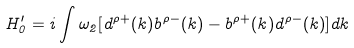<formula> <loc_0><loc_0><loc_500><loc_500>H _ { 0 } ^ { \prime } = i \int \omega _ { 2 } [ d ^ { \rho + } ( k ) b ^ { \rho - } ( k ) - b ^ { \rho + } ( k ) d ^ { \rho - } ( k ) ] d k</formula> 